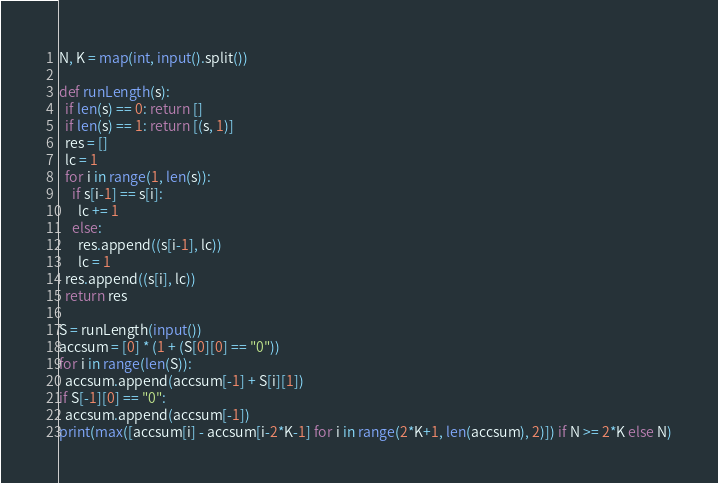<code> <loc_0><loc_0><loc_500><loc_500><_Python_>N, K = map(int, input().split())

def runLength(s):
  if len(s) == 0: return []
  if len(s) == 1: return [(s, 1)]
  res = []
  lc = 1
  for i in range(1, len(s)):
    if s[i-1] == s[i]:
      lc += 1
    else:
      res.append((s[i-1], lc))
      lc = 1
  res.append((s[i], lc))
  return res

S = runLength(input())
accsum = [0] * (1 + (S[0][0] == "0"))
for i in range(len(S)):
  accsum.append(accsum[-1] + S[i][1])
if S[-1][0] == "0":
  accsum.append(accsum[-1])
print(max([accsum[i] - accsum[i-2*K-1] for i in range(2*K+1, len(accsum), 2)]) if N >= 2*K else N)</code> 